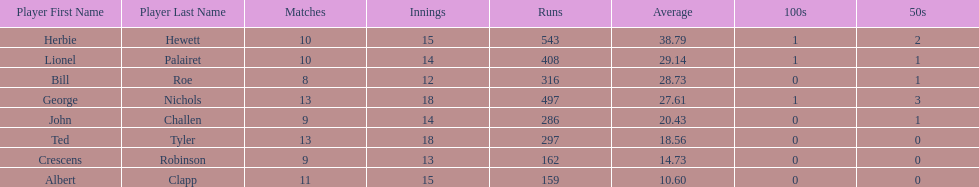What is the least about of runs anyone has? 159. 